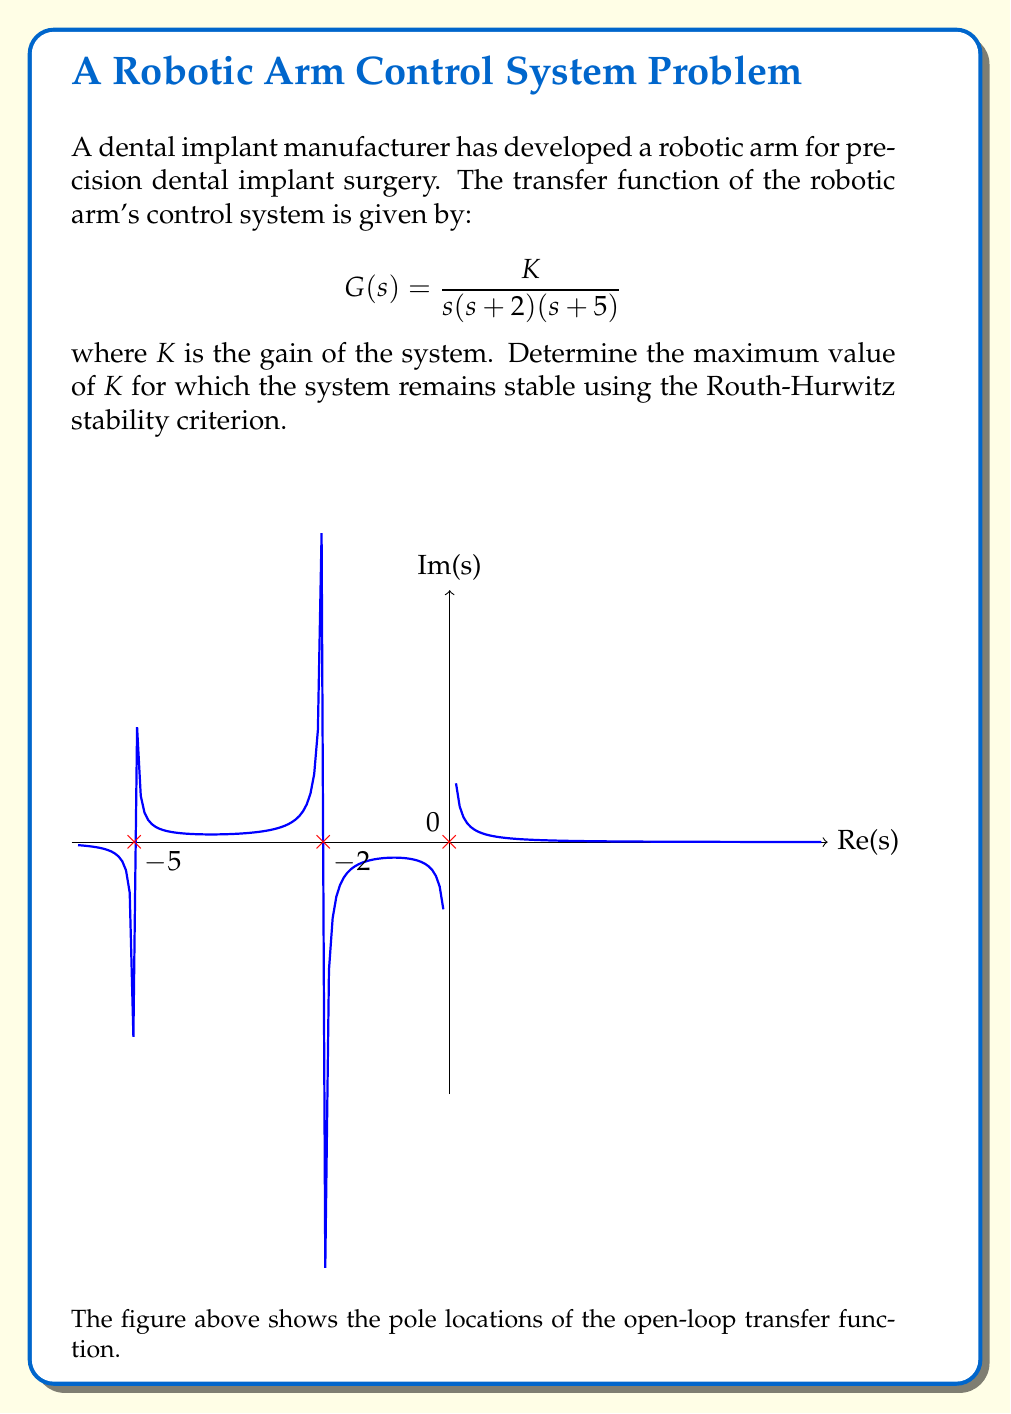Solve this math problem. To analyze the stability using the Routh-Hurwitz criterion, we follow these steps:

1) First, we need to find the characteristic equation. The closed-loop transfer function is:

   $$T(s) = \frac{G(s)}{1 + G(s)} = \frac{K}{s(s + 2)(s + 5) + K}$$

2) The characteristic equation is the denominator of T(s) set to zero:

   $$s(s + 2)(s + 5) + K = 0$$
   $$s^3 + 7s^2 + 10s + K = 0$$

3) Now we construct the Routh array:

   $$\begin{array}{c|c}
   s^3 & 1 & 10 \\
   s^2 & 7 & K \\
   s^1 & \frac{70-K}{7} & 0 \\
   s^0 & K & 0
   \end{array}$$

4) For stability, all elements in the first column must be positive. We already know that 1 and 7 are positive, so we need:

   $$\frac{70-K}{7} > 0 \quad \text{and} \quad K > 0$$

5) From the first inequality:
   $$70 - K > 0$$
   $$K < 70$$

6) Combining this with $K > 0$, we get:

   $$0 < K < 70$$

Therefore, the maximum value of K for which the system remains stable is just under 70.
Answer: $K_{max} \approx 70$ 